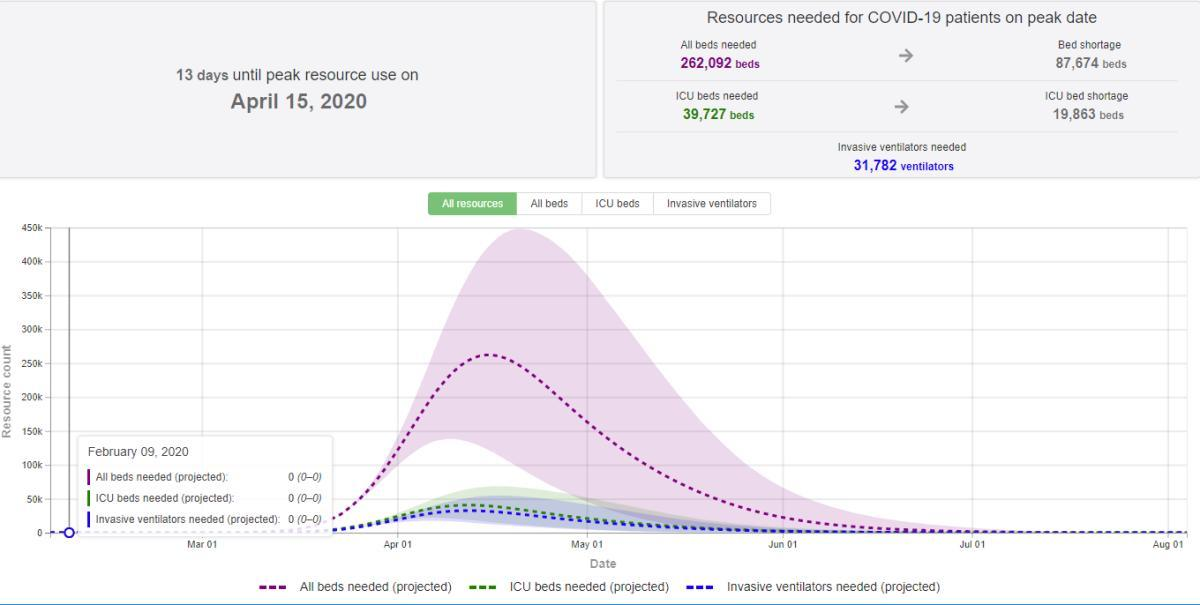How many ICU beds are needed?
Answer the question with a short phrase. 39,727 How many invasive ventilators are needed? 31,782 